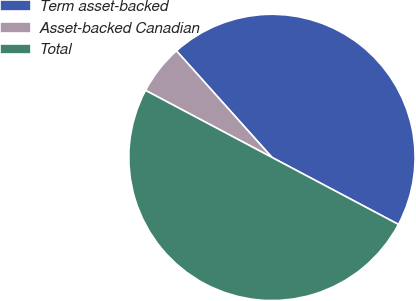Convert chart to OTSL. <chart><loc_0><loc_0><loc_500><loc_500><pie_chart><fcel>Term asset-backed<fcel>Asset-backed Canadian<fcel>Total<nl><fcel>44.39%<fcel>5.61%<fcel>50.01%<nl></chart> 